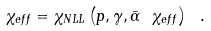<formula> <loc_0><loc_0><loc_500><loc_500>\chi _ { e f f } = \chi _ { N L L } \left ( p , \gamma , \bar { \alpha } \ \chi _ { e f f } \right ) \ .</formula> 